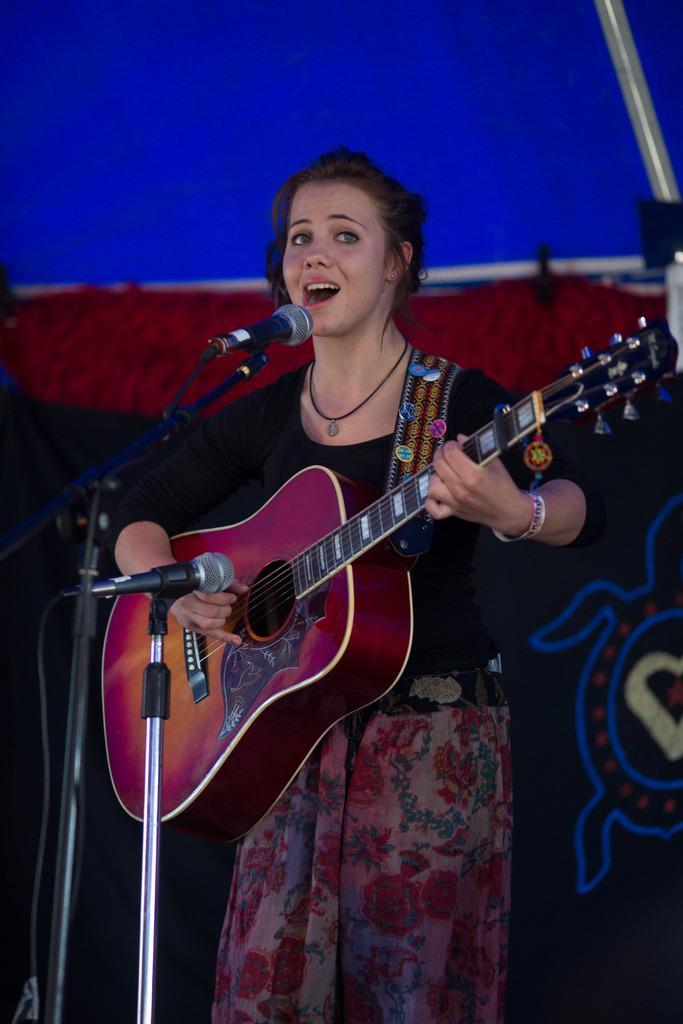Can you describe this image briefly? This woman is highlighted in this picture. This woman wore black t-shirt and playing a guitar in-front of mic. This woman is singing in-front of a mic. 